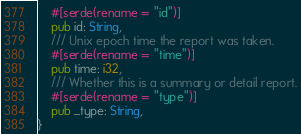<code> <loc_0><loc_0><loc_500><loc_500><_Rust_>    #[serde(rename = "id")]
    pub id: String,
    /// Unix epoch time the report was taken.
    #[serde(rename = "time")]
    pub time: i32,
    /// Whether this is a summary or detail report.
    #[serde(rename = "type")]
    pub _type: String,
}
</code> 